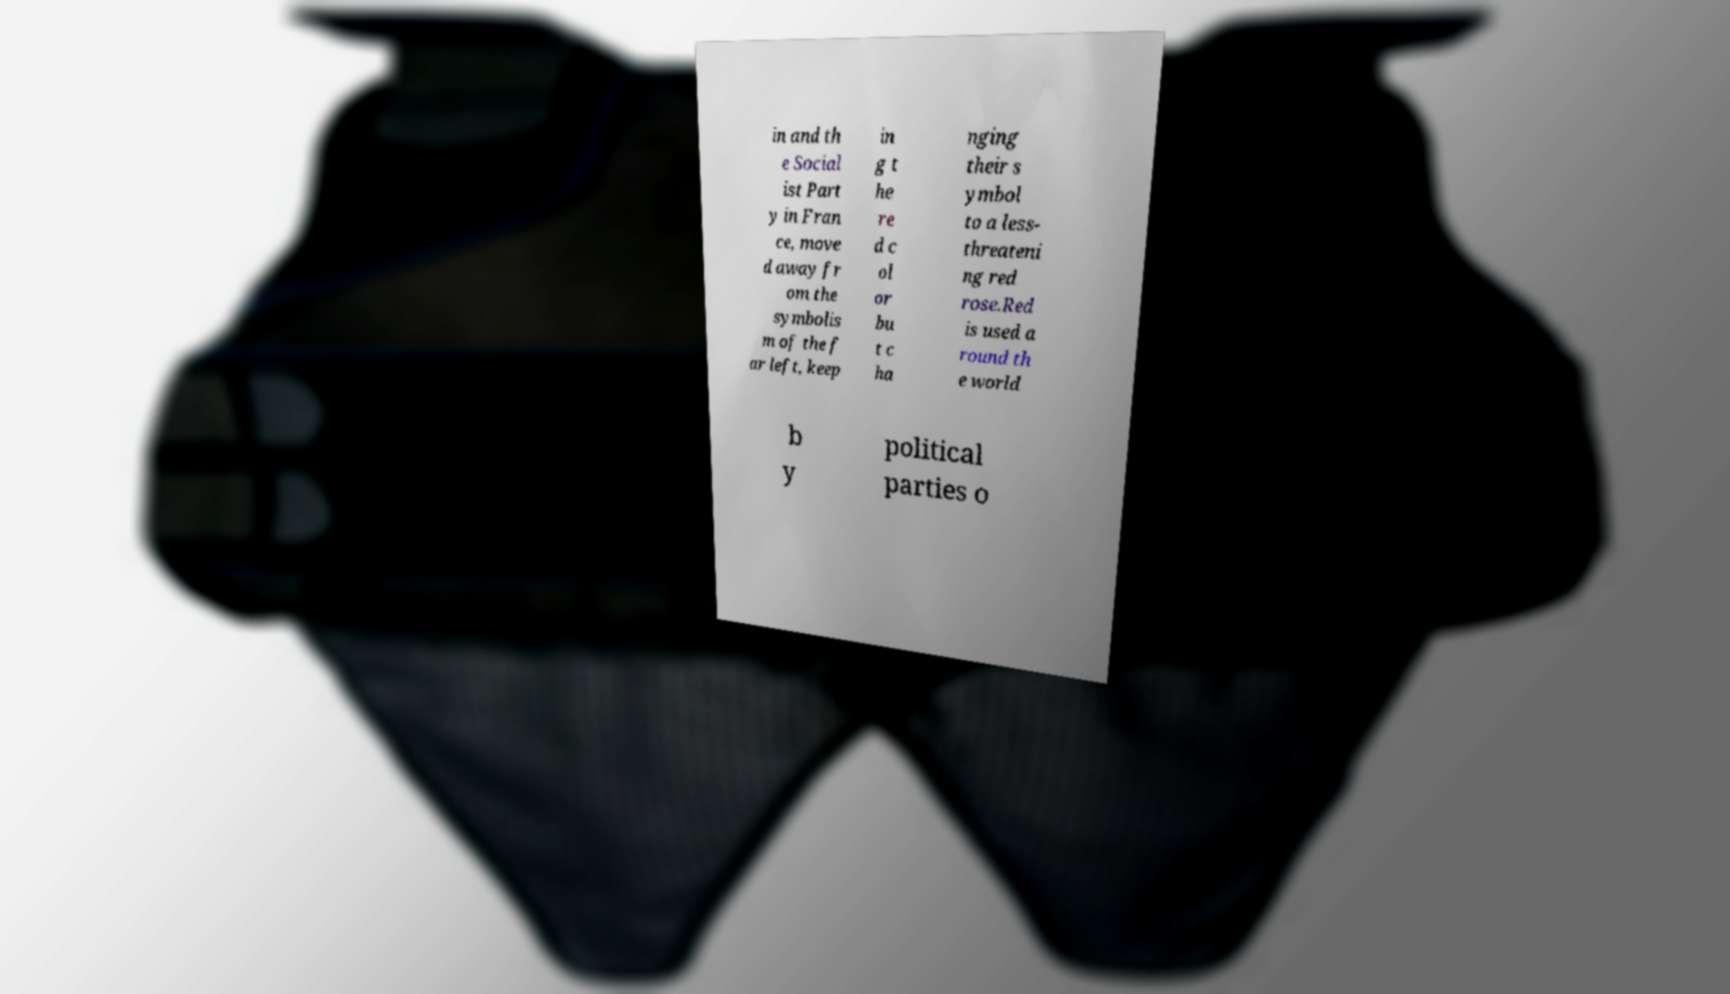I need the written content from this picture converted into text. Can you do that? in and th e Social ist Part y in Fran ce, move d away fr om the symbolis m of the f ar left, keep in g t he re d c ol or bu t c ha nging their s ymbol to a less- threateni ng red rose.Red is used a round th e world b y political parties o 